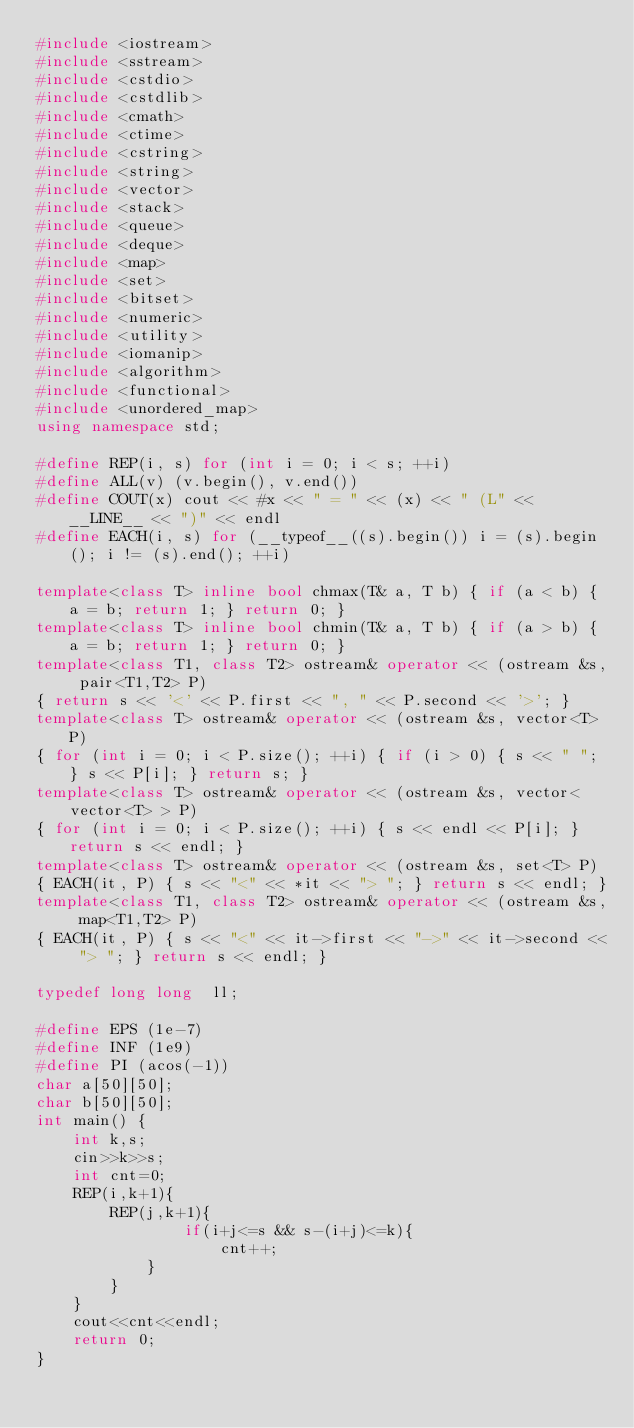<code> <loc_0><loc_0><loc_500><loc_500><_C++_>#include <iostream>
#include <sstream>
#include <cstdio>
#include <cstdlib>
#include <cmath>
#include <ctime>
#include <cstring>
#include <string>
#include <vector>
#include <stack>
#include <queue>
#include <deque>
#include <map>
#include <set>
#include <bitset>
#include <numeric>
#include <utility>
#include <iomanip>
#include <algorithm>
#include <functional>
#include <unordered_map>
using namespace std;

#define REP(i, s) for (int i = 0; i < s; ++i)
#define ALL(v) (v.begin(), v.end())
#define COUT(x) cout << #x << " = " << (x) << " (L" << __LINE__ << ")" << endl
#define EACH(i, s) for (__typeof__((s).begin()) i = (s).begin(); i != (s).end(); ++i)

template<class T> inline bool chmax(T& a, T b) { if (a < b) { a = b; return 1; } return 0; }
template<class T> inline bool chmin(T& a, T b) { if (a > b) { a = b; return 1; } return 0; }
template<class T1, class T2> ostream& operator << (ostream &s, pair<T1,T2> P)
{ return s << '<' << P.first << ", " << P.second << '>'; }
template<class T> ostream& operator << (ostream &s, vector<T> P)
{ for (int i = 0; i < P.size(); ++i) { if (i > 0) { s << " "; } s << P[i]; } return s; }
template<class T> ostream& operator << (ostream &s, vector<vector<T> > P)
{ for (int i = 0; i < P.size(); ++i) { s << endl << P[i]; } return s << endl; }
template<class T> ostream& operator << (ostream &s, set<T> P)
{ EACH(it, P) { s << "<" << *it << "> "; } return s << endl; }
template<class T1, class T2> ostream& operator << (ostream &s, map<T1,T2> P)
{ EACH(it, P) { s << "<" << it->first << "->" << it->second << "> "; } return s << endl; }

typedef long long  ll;

#define EPS (1e-7)
#define INF (1e9)
#define PI (acos(-1))
char a[50][50];
char b[50][50];
int main() {
    int k,s;
    cin>>k>>s;
    int cnt=0;
    REP(i,k+1){
        REP(j,k+1){
                if(i+j<=s && s-(i+j)<=k){
                    cnt++;
            }
        }
    }
    cout<<cnt<<endl;
    return 0;
}</code> 